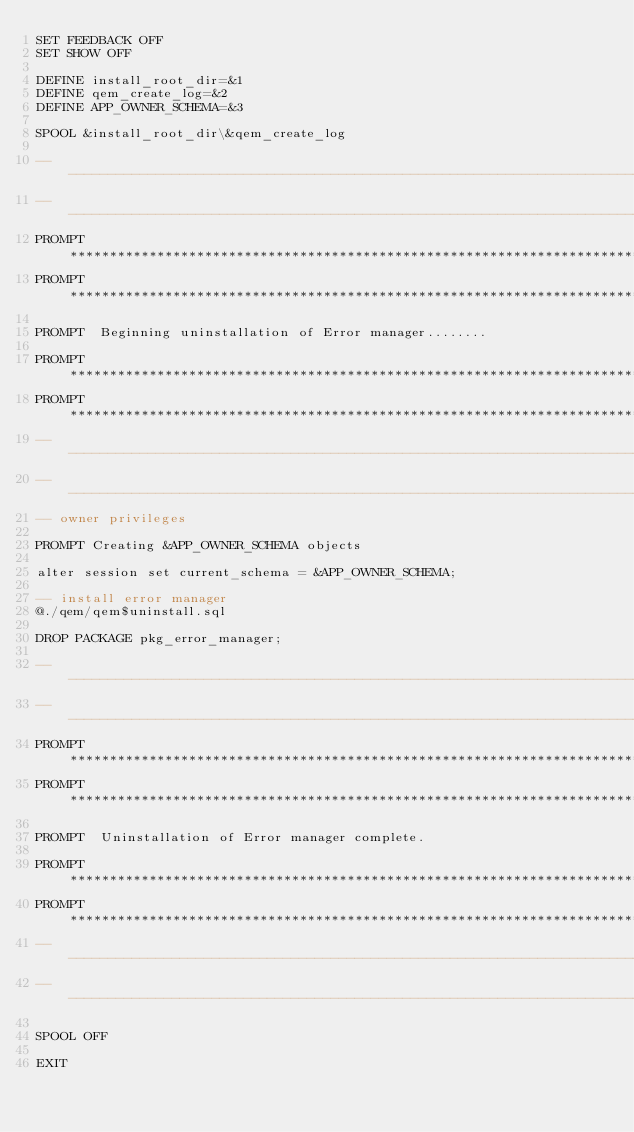<code> <loc_0><loc_0><loc_500><loc_500><_SQL_>SET FEEDBACK OFF
SET SHOW OFF

DEFINE install_root_dir=&1
DEFINE qem_create_log=&2
DEFINE APP_OWNER_SCHEMA=&3

SPOOL &install_root_dir\&qem_create_log

--------------------------------------------------------------------------------------
--------------------------------------------------------------------------------------
PROMPT *******************************************************************************
PROMPT *******************************************************************************

PROMPT	Beginning uninstallation of Error manager........

PROMPT *******************************************************************************
PROMPT *******************************************************************************
--------------------------------------------------------------------------------------
--------------------------------------------------------------------------------------
-- owner privileges

PROMPT Creating &APP_OWNER_SCHEMA objects

alter session set current_schema = &APP_OWNER_SCHEMA;

-- install error manager
@./qem/qem$uninstall.sql

DROP PACKAGE pkg_error_manager;

--------------------------------------------------------------------------------------
--------------------------------------------------------------------------------------
PROMPT *******************************************************************************
PROMPT *******************************************************************************

PROMPT	Uninstallation of Error manager complete.

PROMPT *******************************************************************************
PROMPT *******************************************************************************
--------------------------------------------------------------------------------------
--------------------------------------------------------------------------------------

SPOOL OFF

EXIT</code> 